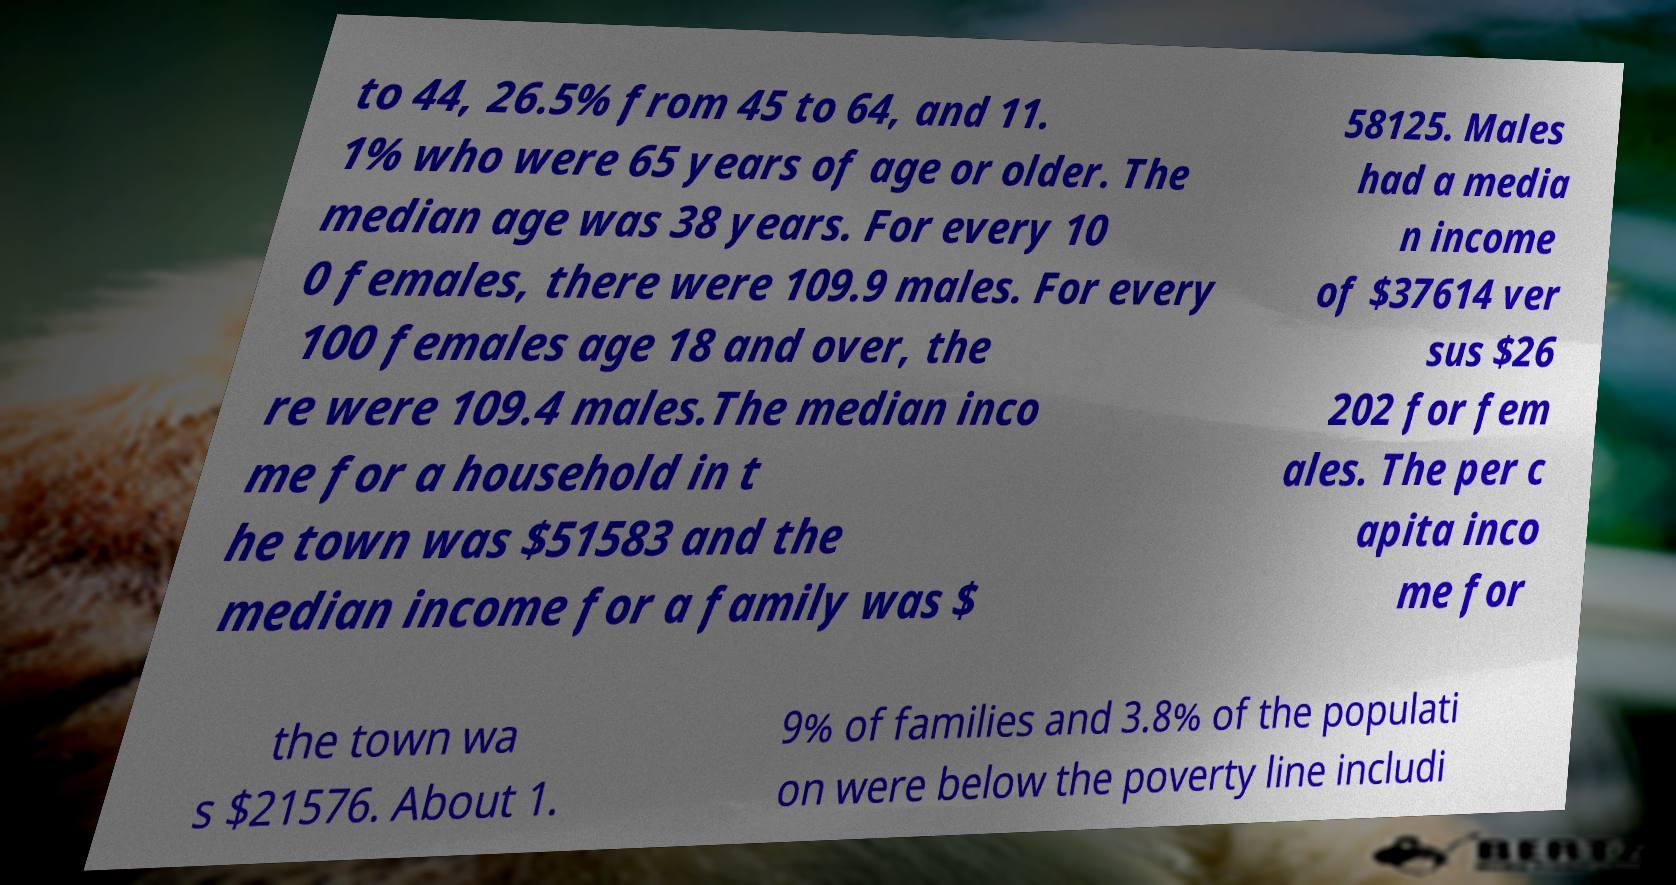Please identify and transcribe the text found in this image. to 44, 26.5% from 45 to 64, and 11. 1% who were 65 years of age or older. The median age was 38 years. For every 10 0 females, there were 109.9 males. For every 100 females age 18 and over, the re were 109.4 males.The median inco me for a household in t he town was $51583 and the median income for a family was $ 58125. Males had a media n income of $37614 ver sus $26 202 for fem ales. The per c apita inco me for the town wa s $21576. About 1. 9% of families and 3.8% of the populati on were below the poverty line includi 